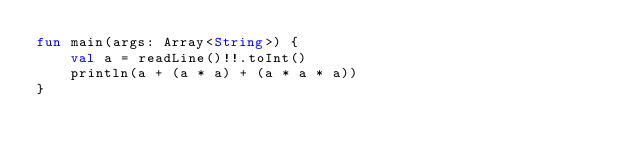<code> <loc_0><loc_0><loc_500><loc_500><_Kotlin_>fun main(args: Array<String>) {
    val a = readLine()!!.toInt()
    println(a + (a * a) + (a * a * a))
}
</code> 